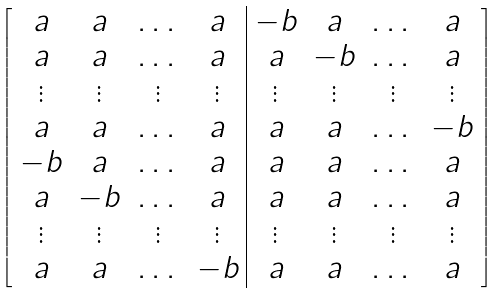Convert formula to latex. <formula><loc_0><loc_0><loc_500><loc_500>\left [ \begin{array} { c c c c | c c c c } a & a & \dots & a & - b & a & \dots & a \\ a & a & \dots & a & a & - b & \dots & a \\ \vdots & \vdots & \vdots & \vdots & \vdots & \vdots & \vdots & \vdots \\ a & a & \dots & a & a & a & \dots & - b \\ - b & a & \dots & a & a & a & \dots & a \\ a & - b & \dots & a & a & a & \dots & a \\ \vdots & \vdots & \vdots & \vdots & \vdots & \vdots & \vdots & \vdots \\ a & a & \dots & - b & a & a & \dots & a \end{array} \right ]</formula> 